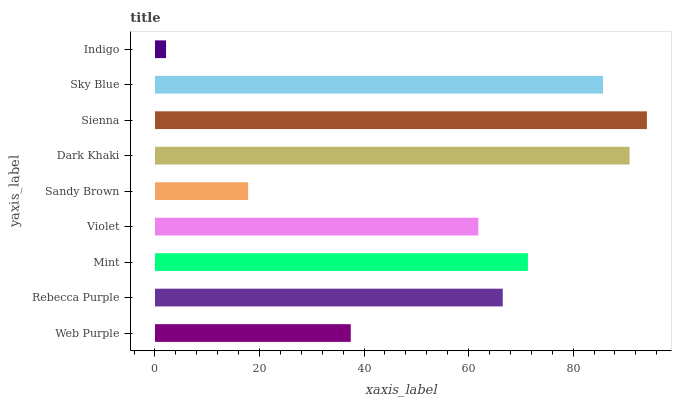Is Indigo the minimum?
Answer yes or no. Yes. Is Sienna the maximum?
Answer yes or no. Yes. Is Rebecca Purple the minimum?
Answer yes or no. No. Is Rebecca Purple the maximum?
Answer yes or no. No. Is Rebecca Purple greater than Web Purple?
Answer yes or no. Yes. Is Web Purple less than Rebecca Purple?
Answer yes or no. Yes. Is Web Purple greater than Rebecca Purple?
Answer yes or no. No. Is Rebecca Purple less than Web Purple?
Answer yes or no. No. Is Rebecca Purple the high median?
Answer yes or no. Yes. Is Rebecca Purple the low median?
Answer yes or no. Yes. Is Indigo the high median?
Answer yes or no. No. Is Mint the low median?
Answer yes or no. No. 